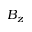<formula> <loc_0><loc_0><loc_500><loc_500>B _ { z }</formula> 